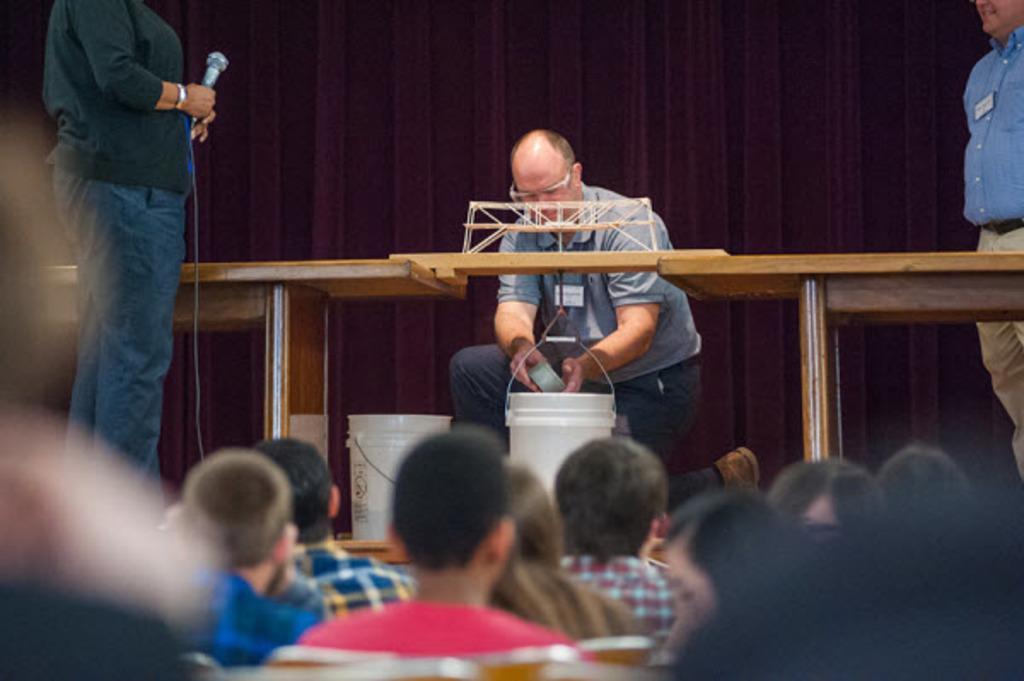Can you describe this image briefly? In this picture we can see group of people, on the left side of the image we can see a person and the person is holding a microphone, in the middle of the image we can see a man, he is holding an object, in front of him we can see buckets. 